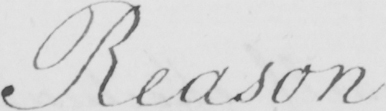Please provide the text content of this handwritten line. Reason 